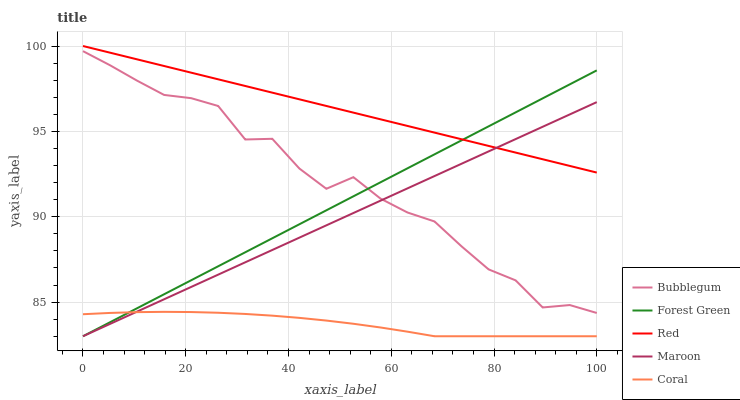Does Coral have the minimum area under the curve?
Answer yes or no. Yes. Does Red have the maximum area under the curve?
Answer yes or no. Yes. Does Maroon have the minimum area under the curve?
Answer yes or no. No. Does Maroon have the maximum area under the curve?
Answer yes or no. No. Is Maroon the smoothest?
Answer yes or no. Yes. Is Bubblegum the roughest?
Answer yes or no. Yes. Is Forest Green the smoothest?
Answer yes or no. No. Is Forest Green the roughest?
Answer yes or no. No. Does Coral have the lowest value?
Answer yes or no. Yes. Does Red have the lowest value?
Answer yes or no. No. Does Red have the highest value?
Answer yes or no. Yes. Does Maroon have the highest value?
Answer yes or no. No. Is Bubblegum less than Red?
Answer yes or no. Yes. Is Red greater than Coral?
Answer yes or no. Yes. Does Red intersect Maroon?
Answer yes or no. Yes. Is Red less than Maroon?
Answer yes or no. No. Is Red greater than Maroon?
Answer yes or no. No. Does Bubblegum intersect Red?
Answer yes or no. No. 